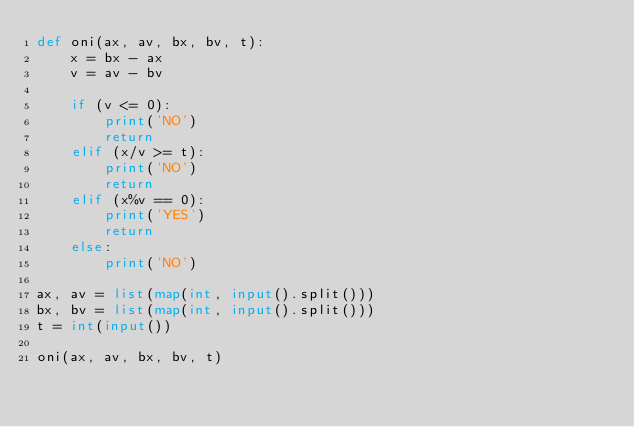Convert code to text. <code><loc_0><loc_0><loc_500><loc_500><_Python_>def oni(ax, av, bx, bv, t):
    x = bx - ax
    v = av - bv

    if (v <= 0):
        print('NO')
        return
    elif (x/v >= t):
        print('NO')
        return
    elif (x%v == 0): 
        print('YES')
        return
    else:
        print('NO')

ax, av = list(map(int, input().split()))
bx, bv = list(map(int, input().split()))
t = int(input())

oni(ax, av, bx, bv, t)
</code> 